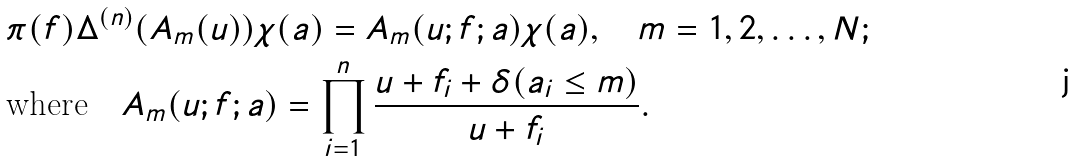Convert formula to latex. <formula><loc_0><loc_0><loc_500><loc_500>& \pi ( f ) \Delta ^ { ( n ) } ( A _ { m } ( u ) ) \chi ( a ) = A _ { m } ( u ; f ; a ) \chi ( a ) , \quad m = 1 , 2 , \dots , N ; \\ & \text {where} \quad A _ { m } ( u ; f ; a ) = \prod _ { i = 1 } ^ { n } \frac { u + f _ { i } + \delta ( a _ { i } \leq m ) } { u + f _ { i } } .</formula> 